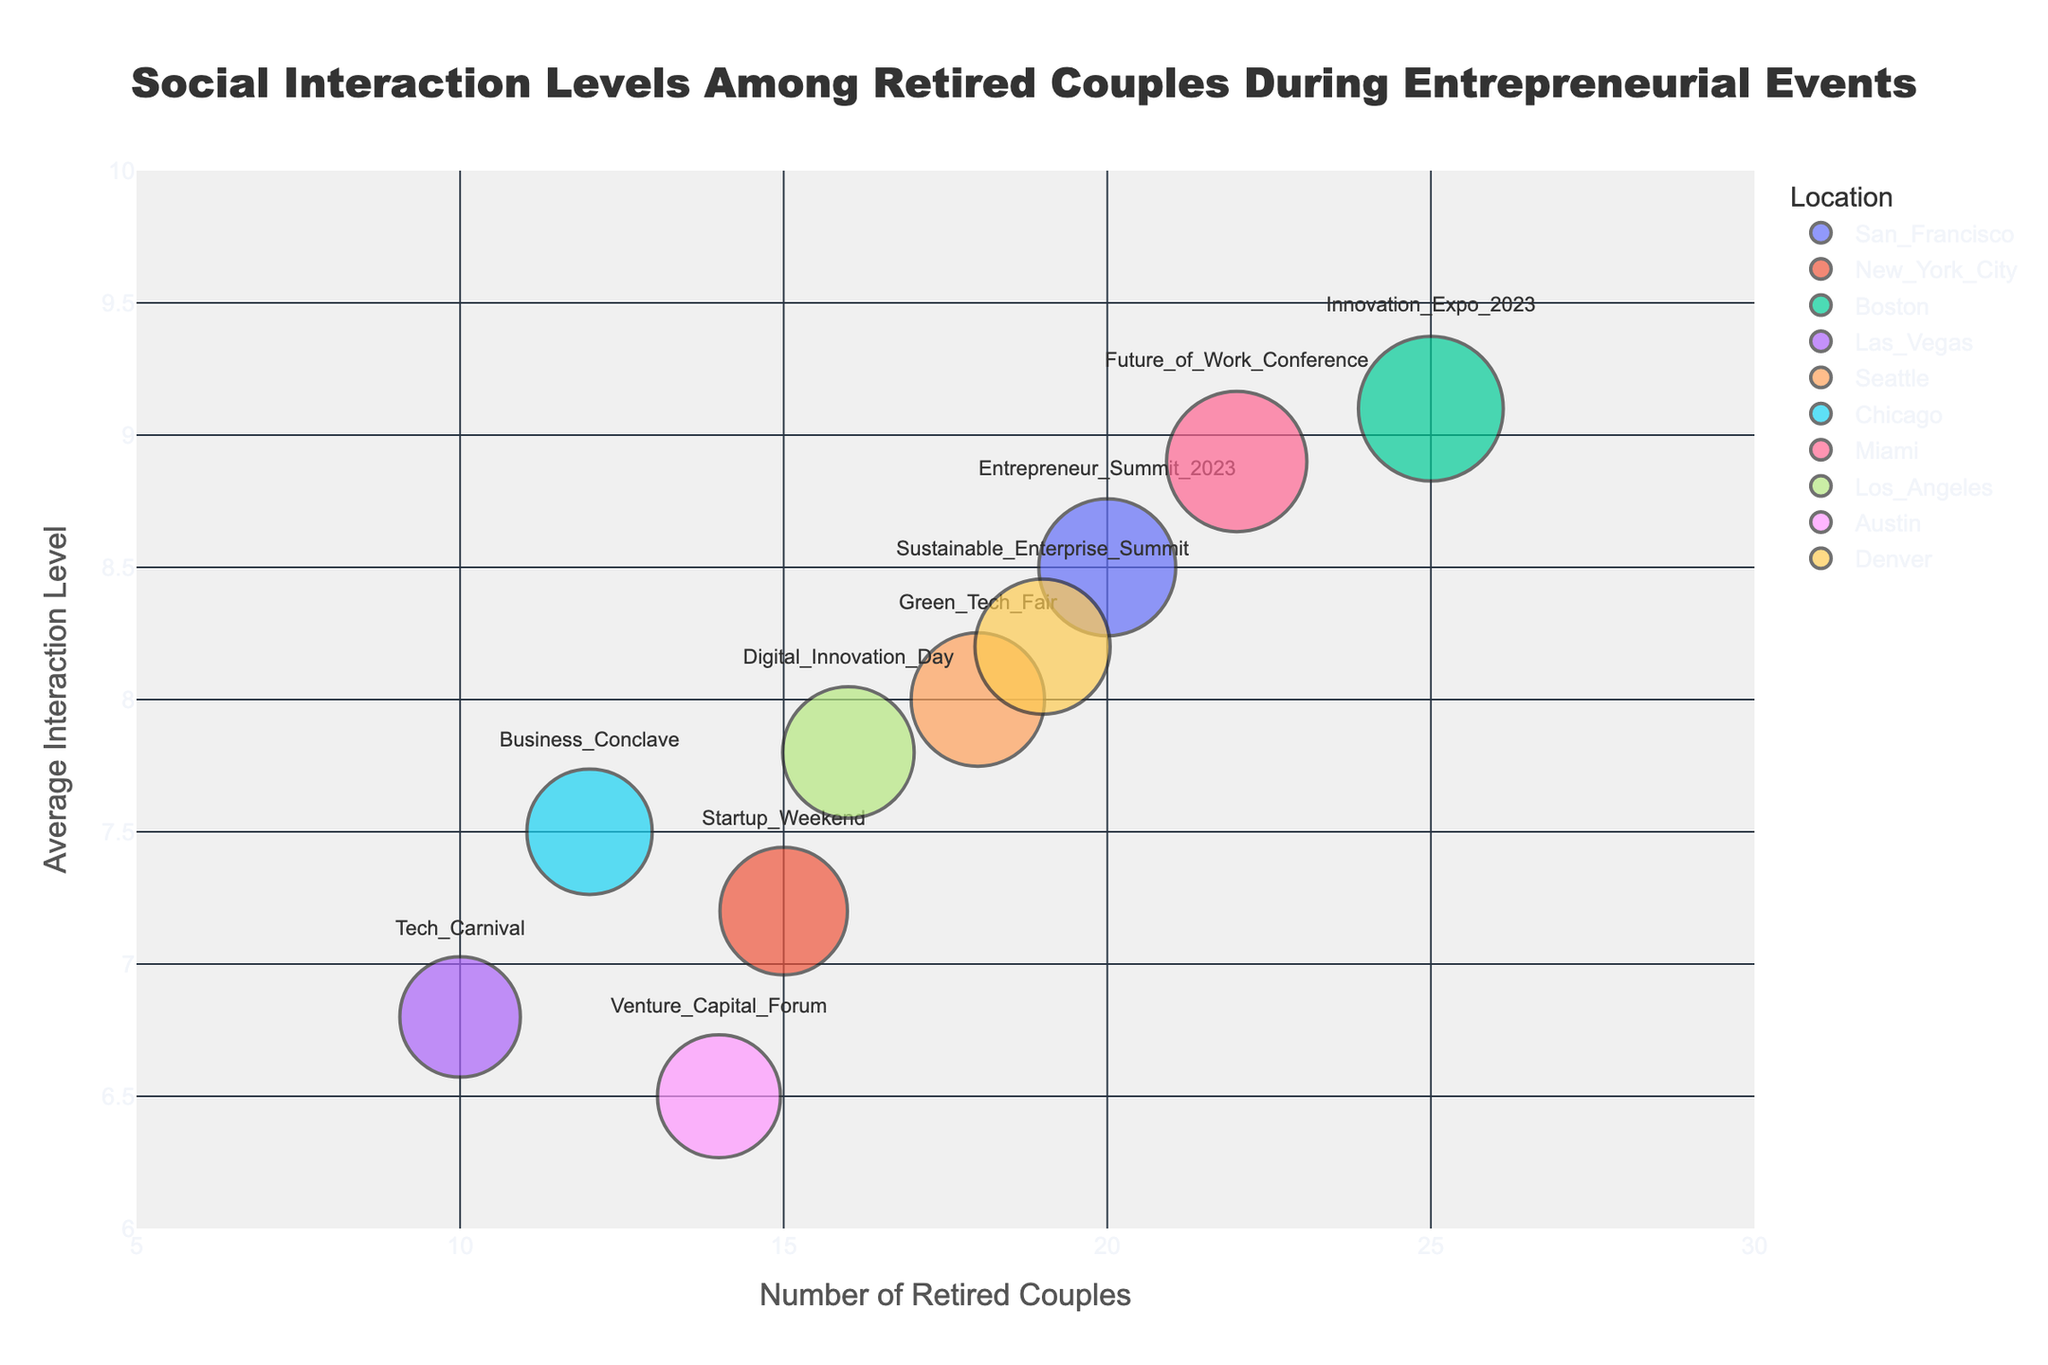what is the title of the figure? The title is usually located at the top of the chart, often in a larger font size, making it easy to identify. In this case, it describes the theme of the figure which is "Social Interaction Levels Among Retired Couples During Entrepreneurial Events".
Answer: Social Interaction Levels Among Retired Couples During Entrepreneurial Events What's the x-axis title? The x-axis title is typically positioned below the x-axis. In this figure, it's labeled to describe the data displayed along the horizontal axis, which is "Number of Retired Couples".
Answer: Number of Retired Couples Which event had the highest Average Interaction Level? Look at the y-axis and find the bubble positioned highest. The event at this position will have the highest Average Interaction Level. In this case, it's "Innovation Expo 2023".
Answer: Innovation Expo 2023 Which event in Las Vegas has the least number of retired couples attending? Identify the bubble colored corresponding to Las Vegas and then look at its position along the x-axis for the Number of Retired Couples. Here, it's "Tech Carnival".
Answer: Tech Carnival What's the average interaction level for events with 20 or more retired couples? Identify the bubbles where the Number of Retired Couples is 20 or more. These events are "Entrepreneur Summit 2023", "Innovation Expo 2023", and "Future of Work Conference". Their average interaction levels are 8.5, 9.1, and 8.9. Calculate the average: (8.5 + 9.1 + 8.9) / 3 = 8.83.
Answer: 8.83 What is the general trend between the number of retired couples and their average interaction level? Look for a pattern in the distribution of bubbles. Generally, a higher number of retired couples tend to have higher average interaction levels.
Answer: Positive correlation Which event has the largest bubble size and in which city is it? The largest bubble represents the event with the most Total Participants. Scan for the largest bubble and identify the event and its city. It's "Innovation Expo 2023" in Boston.
Answer: Innovation Expo 2023, Boston What is the difference in Average Interaction Level between "Business Conclave" and "Tech Carnival"? Find their positions along the y-axis. "Business Conclave" is at 7.5 and "Tech Carnival" is at 6.8. Subtract to find the difference: 7.5 - 6.8 = 0.7.
Answer: 0.7 Which event has the smallest bubble and what is its total participants' count? The smallest bubble represents the event with the least Total Participants. Scan for the smallest bubble and check the corresponding event. It's "Tech Carnival" with 120 total participants.
Answer: Tech Carnival, 120 Which location hosted the most well-attended events in terms of retired couples? Count the number of bubbles per location and compare the counts. The location with the highest count hosts "Innovation Expo 2023" and has the highest number of retired couples (25).
Answer: Boston 